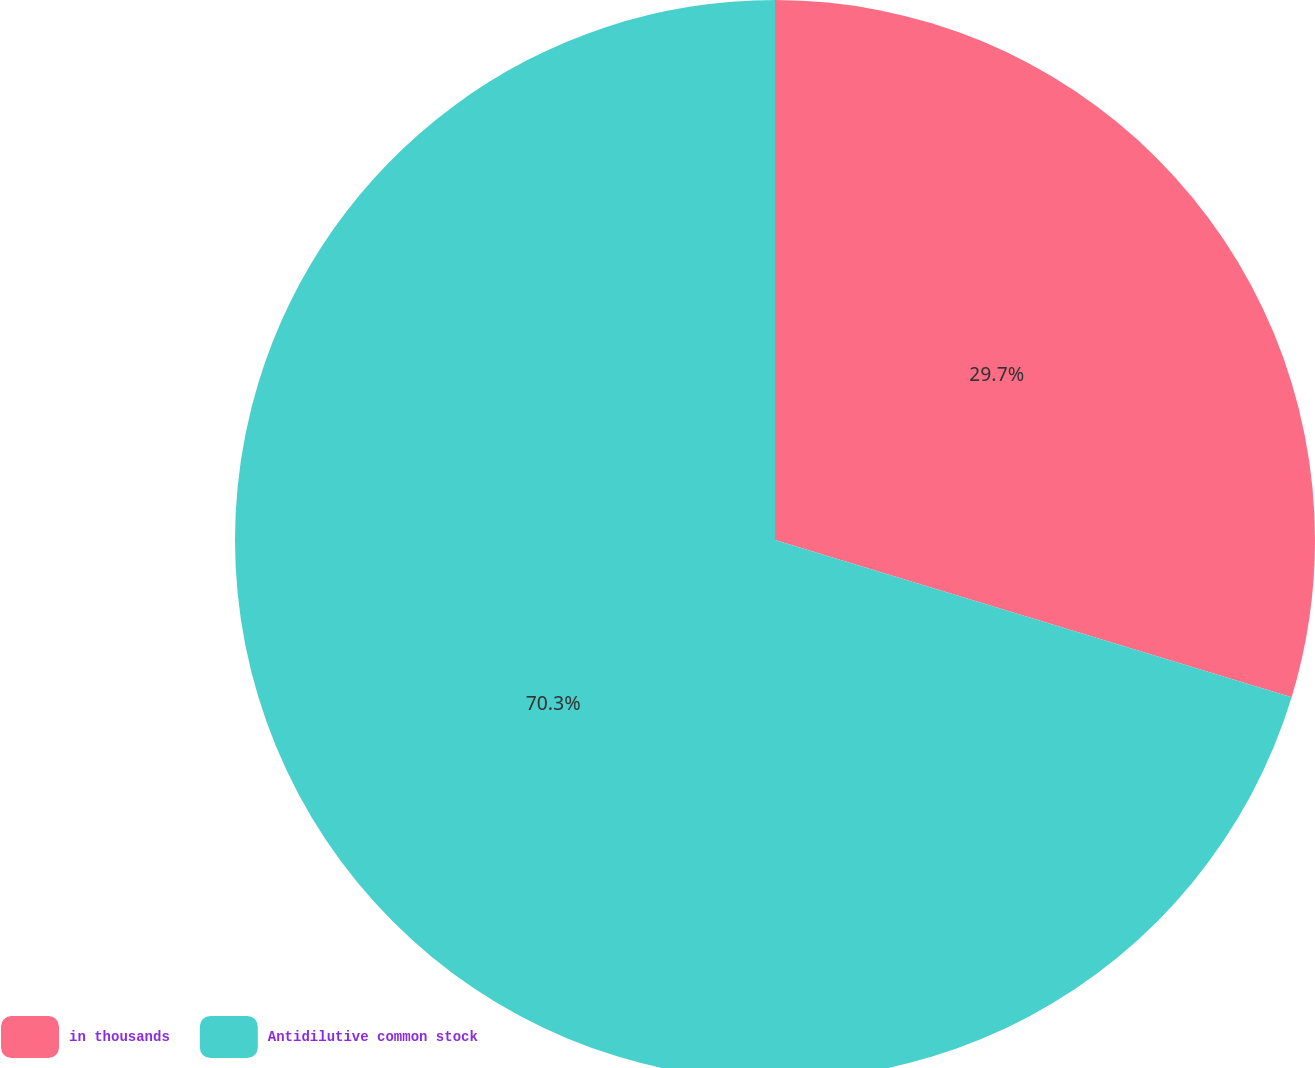<chart> <loc_0><loc_0><loc_500><loc_500><pie_chart><fcel>in thousands<fcel>Antidilutive common stock<nl><fcel>29.7%<fcel>70.3%<nl></chart> 